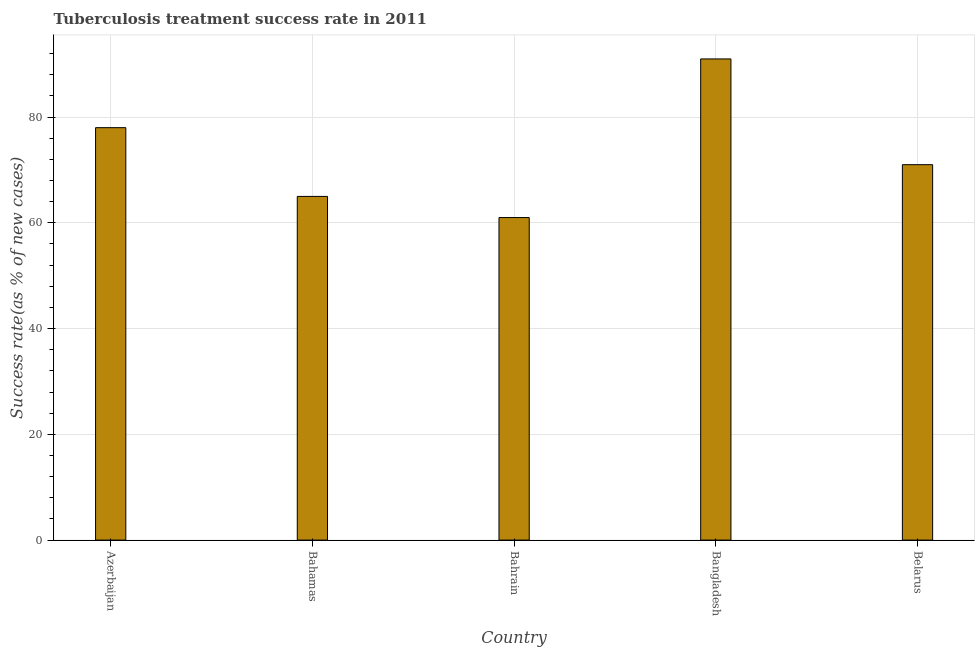Does the graph contain any zero values?
Provide a short and direct response. No. What is the title of the graph?
Offer a terse response. Tuberculosis treatment success rate in 2011. What is the label or title of the X-axis?
Make the answer very short. Country. What is the label or title of the Y-axis?
Make the answer very short. Success rate(as % of new cases). What is the tuberculosis treatment success rate in Belarus?
Make the answer very short. 71. Across all countries, what is the maximum tuberculosis treatment success rate?
Your answer should be very brief. 91. Across all countries, what is the minimum tuberculosis treatment success rate?
Your answer should be very brief. 61. In which country was the tuberculosis treatment success rate maximum?
Make the answer very short. Bangladesh. In which country was the tuberculosis treatment success rate minimum?
Offer a very short reply. Bahrain. What is the sum of the tuberculosis treatment success rate?
Give a very brief answer. 366. What is the average tuberculosis treatment success rate per country?
Your answer should be compact. 73. In how many countries, is the tuberculosis treatment success rate greater than 20 %?
Ensure brevity in your answer.  5. What is the ratio of the tuberculosis treatment success rate in Bahamas to that in Bahrain?
Provide a short and direct response. 1.07. Is the difference between the tuberculosis treatment success rate in Azerbaijan and Bahamas greater than the difference between any two countries?
Keep it short and to the point. No. Is the sum of the tuberculosis treatment success rate in Azerbaijan and Bahamas greater than the maximum tuberculosis treatment success rate across all countries?
Keep it short and to the point. Yes. What is the difference between the highest and the lowest tuberculosis treatment success rate?
Keep it short and to the point. 30. How many bars are there?
Ensure brevity in your answer.  5. Are all the bars in the graph horizontal?
Give a very brief answer. No. What is the difference between two consecutive major ticks on the Y-axis?
Offer a terse response. 20. Are the values on the major ticks of Y-axis written in scientific E-notation?
Your response must be concise. No. What is the Success rate(as % of new cases) of Azerbaijan?
Provide a short and direct response. 78. What is the Success rate(as % of new cases) in Bahrain?
Ensure brevity in your answer.  61. What is the Success rate(as % of new cases) in Bangladesh?
Make the answer very short. 91. What is the Success rate(as % of new cases) in Belarus?
Offer a terse response. 71. What is the difference between the Success rate(as % of new cases) in Azerbaijan and Bangladesh?
Your answer should be compact. -13. What is the difference between the Success rate(as % of new cases) in Bahamas and Bahrain?
Your answer should be compact. 4. What is the difference between the Success rate(as % of new cases) in Bahamas and Bangladesh?
Keep it short and to the point. -26. What is the difference between the Success rate(as % of new cases) in Bahrain and Bangladesh?
Provide a succinct answer. -30. What is the difference between the Success rate(as % of new cases) in Bangladesh and Belarus?
Provide a short and direct response. 20. What is the ratio of the Success rate(as % of new cases) in Azerbaijan to that in Bahamas?
Ensure brevity in your answer.  1.2. What is the ratio of the Success rate(as % of new cases) in Azerbaijan to that in Bahrain?
Give a very brief answer. 1.28. What is the ratio of the Success rate(as % of new cases) in Azerbaijan to that in Bangladesh?
Your answer should be compact. 0.86. What is the ratio of the Success rate(as % of new cases) in Azerbaijan to that in Belarus?
Offer a terse response. 1.1. What is the ratio of the Success rate(as % of new cases) in Bahamas to that in Bahrain?
Your answer should be compact. 1.07. What is the ratio of the Success rate(as % of new cases) in Bahamas to that in Bangladesh?
Make the answer very short. 0.71. What is the ratio of the Success rate(as % of new cases) in Bahamas to that in Belarus?
Make the answer very short. 0.92. What is the ratio of the Success rate(as % of new cases) in Bahrain to that in Bangladesh?
Your response must be concise. 0.67. What is the ratio of the Success rate(as % of new cases) in Bahrain to that in Belarus?
Your response must be concise. 0.86. What is the ratio of the Success rate(as % of new cases) in Bangladesh to that in Belarus?
Your answer should be compact. 1.28. 